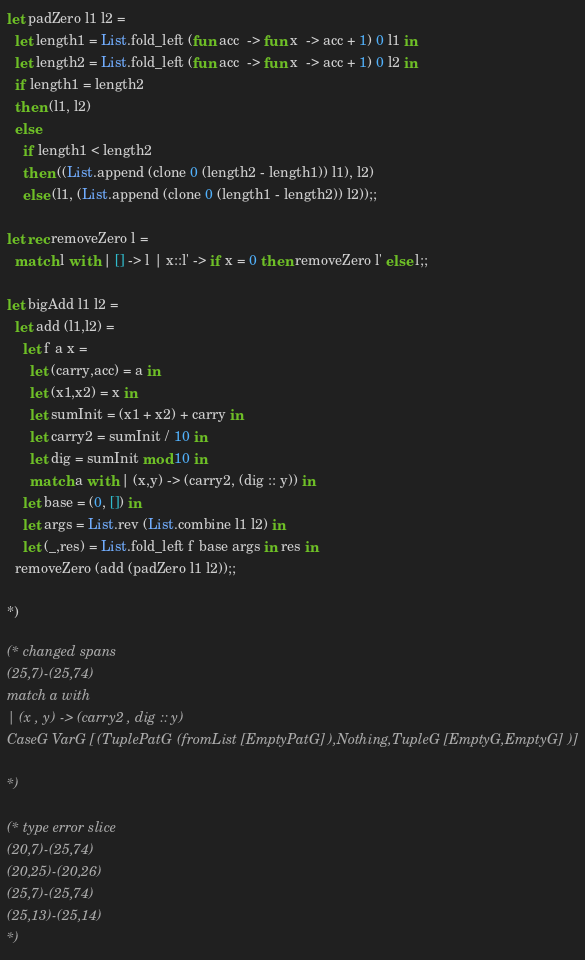<code> <loc_0><loc_0><loc_500><loc_500><_OCaml_>let padZero l1 l2 =
  let length1 = List.fold_left (fun acc  -> fun x  -> acc + 1) 0 l1 in
  let length2 = List.fold_left (fun acc  -> fun x  -> acc + 1) 0 l2 in
  if length1 = length2
  then (l1, l2)
  else
    if length1 < length2
    then ((List.append (clone 0 (length2 - length1)) l1), l2)
    else (l1, (List.append (clone 0 (length1 - length2)) l2));;

let rec removeZero l =
  match l with | [] -> l | x::l' -> if x = 0 then removeZero l' else l;;

let bigAdd l1 l2 =
  let add (l1,l2) =
    let f a x =
      let (carry,acc) = a in
      let (x1,x2) = x in
      let sumInit = (x1 + x2) + carry in
      let carry2 = sumInit / 10 in
      let dig = sumInit mod 10 in
      match a with | (x,y) -> (carry2, (dig :: y)) in
    let base = (0, []) in
    let args = List.rev (List.combine l1 l2) in
    let (_,res) = List.fold_left f base args in res in
  removeZero (add (padZero l1 l2));;

*)

(* changed spans
(25,7)-(25,74)
match a with
| (x , y) -> (carry2 , dig :: y)
CaseG VarG [(TuplePatG (fromList [EmptyPatG]),Nothing,TupleG [EmptyG,EmptyG])]

*)

(* type error slice
(20,7)-(25,74)
(20,25)-(20,26)
(25,7)-(25,74)
(25,13)-(25,14)
*)
</code> 